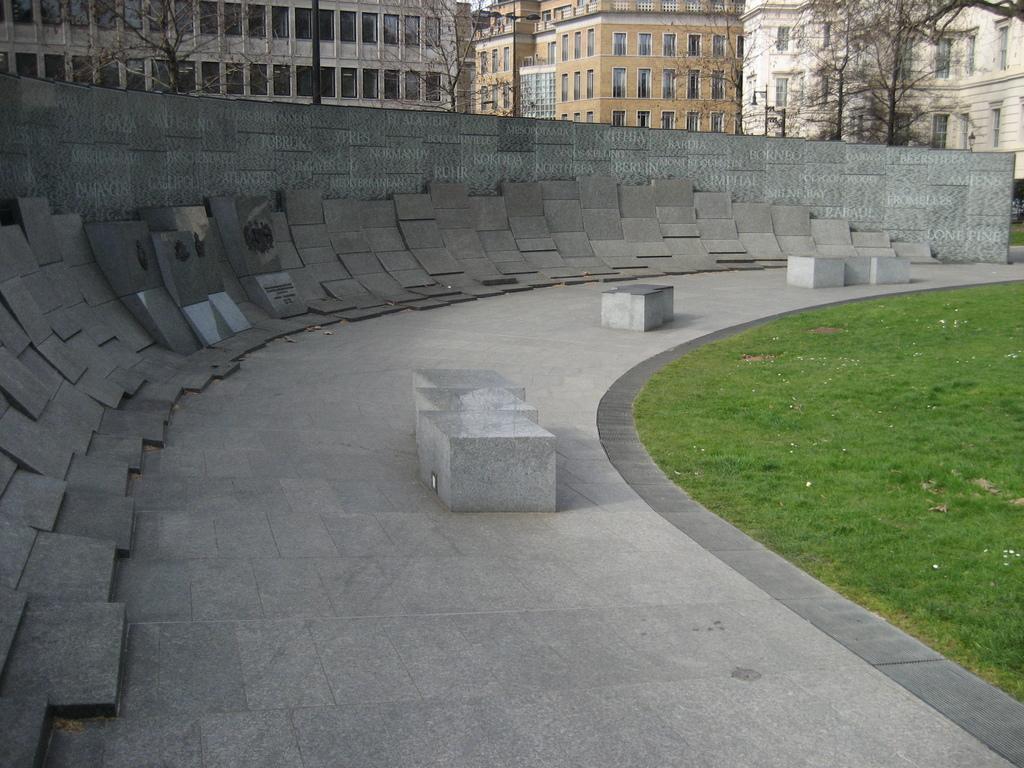How would you summarize this image in a sentence or two? In this image at the bottom there is a walkway and some boards, on the right side there is a grass. In the background there are some buildings, trees and poles. 